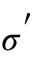<formula> <loc_0><loc_0><loc_500><loc_500>\sigma ^ { ^ { \prime } }</formula> 